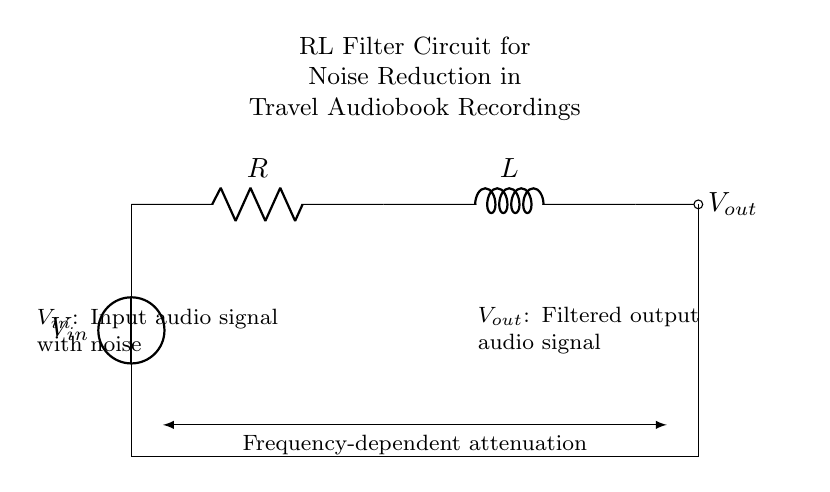What type of circuit is shown? The circuit is an RL filter circuit, which combines a resistor and an inductor in a specific configuration to filter signals. The presence of both R and L components indicates it is indeed an RL circuit.
Answer: RL filter circuit What is the role of the resistor? The resistor (R) in the circuit plays a crucial role in setting the level of current flowing in the circuit and influences the cut-off frequency of the filter. It also dissipates energy as heat, helping to reduce signal amplitude.
Answer: Current regulation What does $V_{in}$ represent? $V_{in}$ represents the input audio signal, which may contain noise. This is the signal that enters the filter before any processing occurs.
Answer: Noise-affected audio signal What does $V_{out}$ represent? $V_{out}$ represents the output audio signal, which has been processed by the RL filter to reduce noise, ideally providing a cleaner sound for the audiobook recordings.
Answer: Filtered audio signal How does frequency affect the output? The output voltage $V_{out}$ is frequency-dependent, meaning that the RL filter attenuates signals based on their frequency. High frequencies are more strongly attenuated than lower frequencies due to the inductor's reactance increasing with frequency.
Answer: Frequency-dependent attenuation What determines the cut-off frequency in this circuit? The cut-off frequency is determined by both the resistance (R) and the inductance (L) values according to the formula f_c = R / (2πL). This relationship dictates how the circuit will respond to various frequencies.
Answer: R and L values What is a potential application of this circuit? This RL filter circuit can be used in noise reduction systems specifically for high-quality travel audiobook recordings, helping to enhance the listening experience by minimizing unwanted audio artifacts.
Answer: Noise reduction in audiobooks 